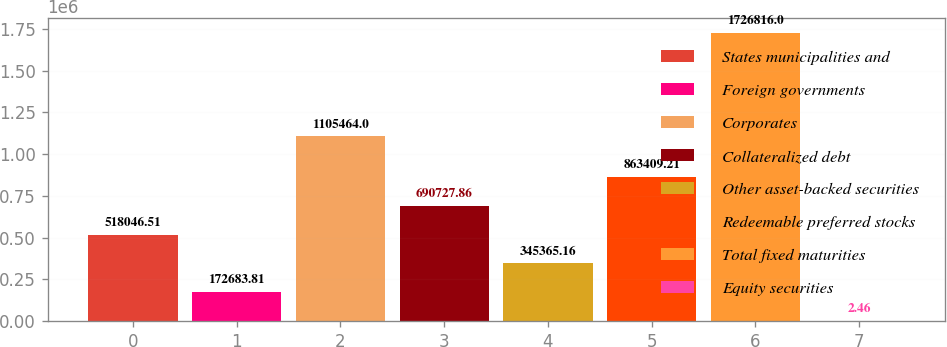<chart> <loc_0><loc_0><loc_500><loc_500><bar_chart><fcel>States municipalities and<fcel>Foreign governments<fcel>Corporates<fcel>Collateralized debt<fcel>Other asset-backed securities<fcel>Redeemable preferred stocks<fcel>Total fixed maturities<fcel>Equity securities<nl><fcel>518047<fcel>172684<fcel>1.10546e+06<fcel>690728<fcel>345365<fcel>863409<fcel>1.72682e+06<fcel>2.46<nl></chart> 